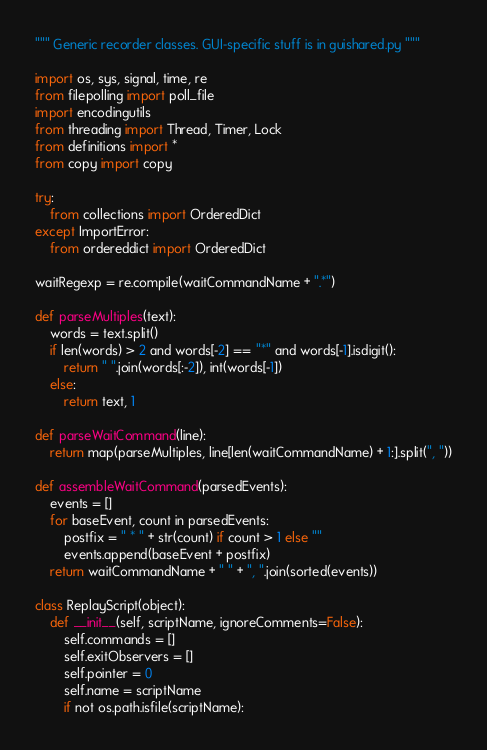Convert code to text. <code><loc_0><loc_0><loc_500><loc_500><_Python_>
""" Generic recorder classes. GUI-specific stuff is in guishared.py """

import os, sys, signal, time, re
from filepolling import poll_file
import encodingutils
from threading import Thread, Timer, Lock
from definitions import *
from copy import copy

try:
    from collections import OrderedDict
except ImportError:
    from ordereddict import OrderedDict

waitRegexp = re.compile(waitCommandName + ".*")

def parseMultiples(text):
    words = text.split()
    if len(words) > 2 and words[-2] == "*" and words[-1].isdigit():
        return " ".join(words[:-2]), int(words[-1])
    else:
        return text, 1
        
def parseWaitCommand(line):
    return map(parseMultiples, line[len(waitCommandName) + 1:].split(", "))

def assembleWaitCommand(parsedEvents):
    events = []
    for baseEvent, count in parsedEvents:
        postfix = " * " + str(count) if count > 1 else ""
        events.append(baseEvent + postfix)
    return waitCommandName + " " + ", ".join(sorted(events))

class ReplayScript(object):
    def __init__(self, scriptName, ignoreComments=False):
        self.commands = []
        self.exitObservers = []
        self.pointer = 0
        self.name = scriptName
        if not os.path.isfile(scriptName):</code> 